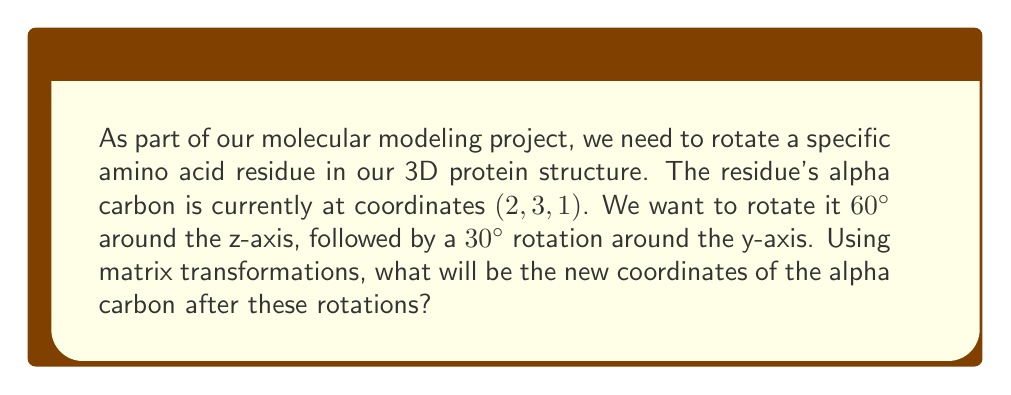Help me with this question. To solve this problem, we'll follow these steps:

1) First, let's recall the rotation matrices for z-axis and y-axis rotations:

   Z-axis rotation (θ):
   $$R_z(\theta) = \begin{pmatrix}
   \cos\theta & -\sin\theta & 0 \\
   \sin\theta & \cos\theta & 0 \\
   0 & 0 & 1
   \end{pmatrix}$$

   Y-axis rotation (φ):
   $$R_y(\phi) = \begin{pmatrix}
   \cos\phi & 0 & \sin\phi \\
   0 & 1 & 0 \\
   -\sin\phi & 0 & \cos\phi
   \end{pmatrix}$$

2) We'll apply the z-axis rotation of 60° first, then the y-axis rotation of 30°. The combined transformation matrix will be:

   $$T = R_y(30°) \cdot R_z(60°)$$

3) Let's calculate $R_z(60°)$:
   $$R_z(60°) = \begin{pmatrix}
   \cos60° & -\sin60° & 0 \\
   \sin60° & \cos60° & 0 \\
   0 & 0 & 1
   \end{pmatrix} = \begin{pmatrix}
   0.5 & -\frac{\sqrt{3}}{2} & 0 \\
   \frac{\sqrt{3}}{2} & 0.5 & 0 \\
   0 & 0 & 1
   \end{pmatrix}$$

4) Now, $R_y(30°)$:
   $$R_y(30°) = \begin{pmatrix}
   \cos30° & 0 & \sin30° \\
   0 & 1 & 0 \\
   -\sin30° & 0 & \cos30°
   \end{pmatrix} = \begin{pmatrix}
   \frac{\sqrt{3}}{2} & 0 & 0.5 \\
   0 & 1 & 0 \\
   -0.5 & 0 & \frac{\sqrt{3}}{2}
   \end{pmatrix}$$

5) Multiply these matrices:
   $$T = R_y(30°) \cdot R_z(60°) = \begin{pmatrix}
   \frac{\sqrt{3}}{2} & 0 & 0.5 \\
   0 & 1 & 0 \\
   -0.5 & 0 & \frac{\sqrt{3}}{2}
   \end{pmatrix} \cdot \begin{pmatrix}
   0.5 & -\frac{\sqrt{3}}{2} & 0 \\
   \frac{\sqrt{3}}{2} & 0.5 & 0 \\
   0 & 0 & 1
   \end{pmatrix}$$

   $$T = \begin{pmatrix}
   \frac{3}{4} & -\frac{\sqrt{3}}{4} & 0.5 \\
   \frac{\sqrt{3}}{2} & 0.5 & 0 \\
   -\frac{\sqrt{3}}{4} & -\frac{1}{4} & \frac{\sqrt{3}}{2}
   \end{pmatrix}$$

6) Now, apply this transformation to the original coordinates (2, 3, 1):

   $$\begin{pmatrix}
   \frac{3}{4} & -\frac{\sqrt{3}}{4} & 0.5 \\
   \frac{\sqrt{3}}{2} & 0.5 & 0 \\
   -\frac{\sqrt{3}}{4} & -\frac{1}{4} & \frac{\sqrt{3}}{2}
   \end{pmatrix} \cdot \begin{pmatrix}
   2 \\
   3 \\
   1
   \end{pmatrix}$$

7) Perform the matrix multiplication:
   $$\begin{pmatrix}
   \frac{3}{2} - \frac{3\sqrt{3}}{4} + 0.5 \\
   \sqrt{3} + \frac{3}{2} \\
   -\frac{\sqrt{3}}{2} - \frac{3}{4} + \frac{\sqrt{3}}{2}
   \end{pmatrix} = \begin{pmatrix}
   1.5 - 1.299 + 0.5 \\
   1.732 + 1.5 \\
   -0.866 - 0.75 + 0.866
   \end{pmatrix}$$
Answer: The new coordinates of the alpha carbon after the rotations are approximately (0.701, 3.232, -0.750). 